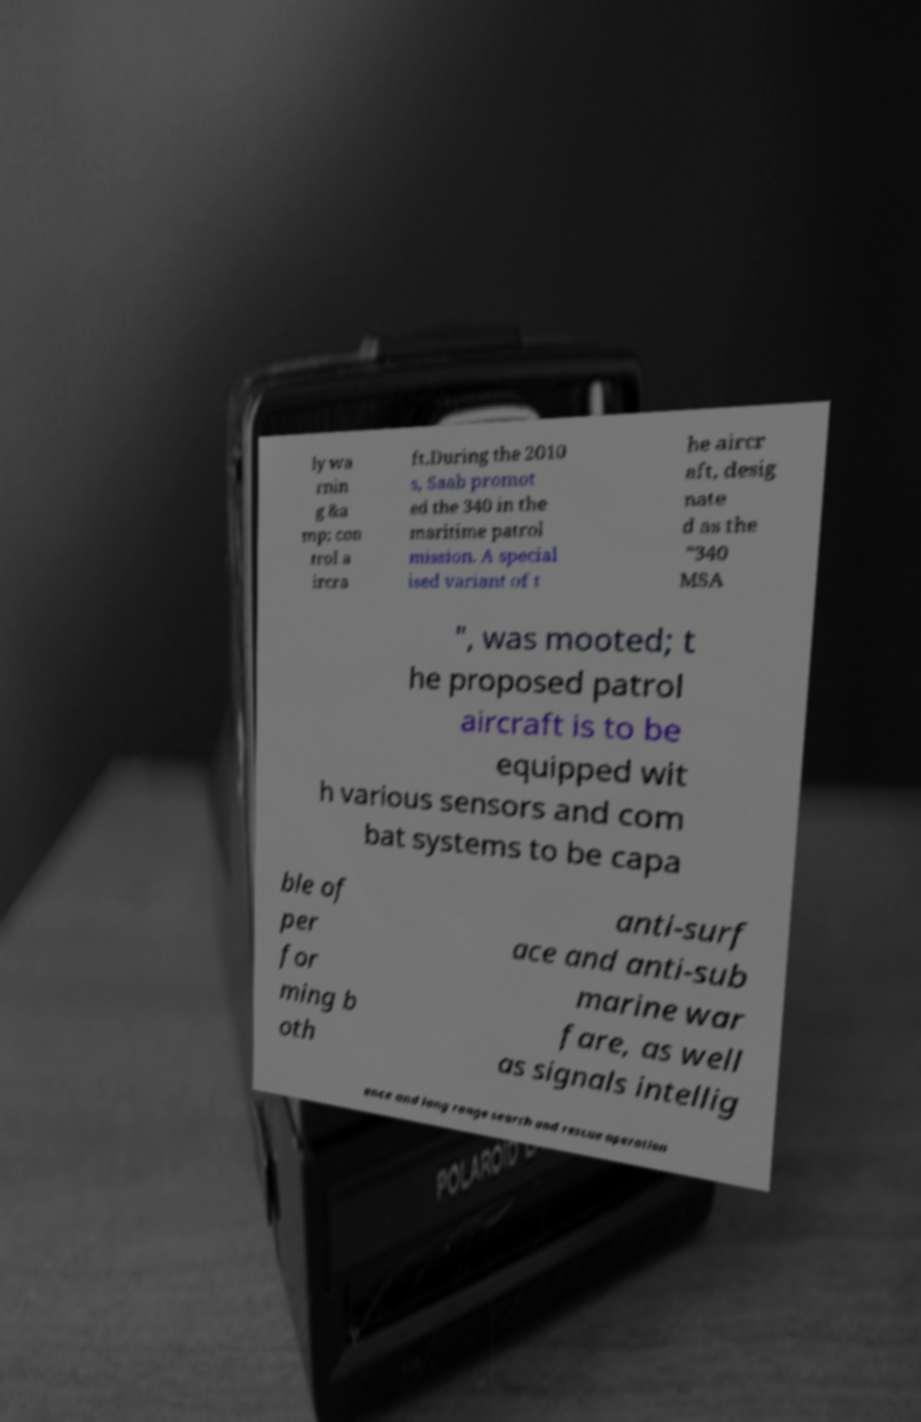For documentation purposes, I need the text within this image transcribed. Could you provide that? ly wa rnin g &a mp; con trol a ircra ft.During the 2010 s, Saab promot ed the 340 in the maritime patrol mission. A special ised variant of t he aircr aft, desig nate d as the "340 MSA ", was mooted; t he proposed patrol aircraft is to be equipped wit h various sensors and com bat systems to be capa ble of per for ming b oth anti-surf ace and anti-sub marine war fare, as well as signals intellig ence and long range search and rescue operation 